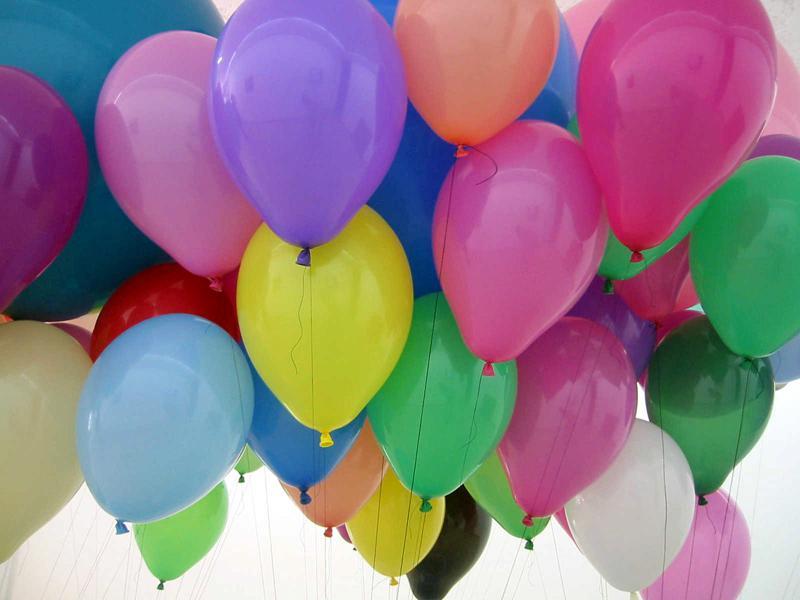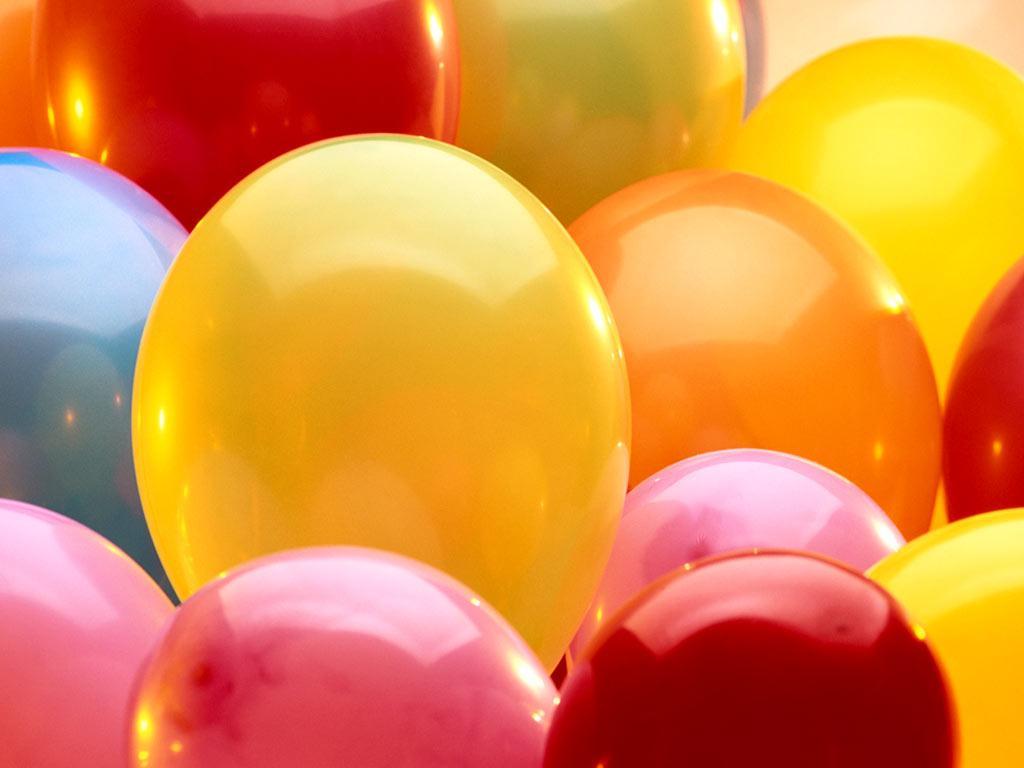The first image is the image on the left, the second image is the image on the right. Examine the images to the left and right. Is the description "In at least one image there is a total of five full balloons." accurate? Answer yes or no. No. The first image is the image on the left, the second image is the image on the right. Evaluate the accuracy of this statement regarding the images: "The left image shows at least four balloons of the same color joined together, and one balloon of a different color.". Is it true? Answer yes or no. No. 